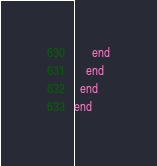Convert code to text. <code><loc_0><loc_0><loc_500><loc_500><_Crystal_>      end
    end
  end
end
</code> 